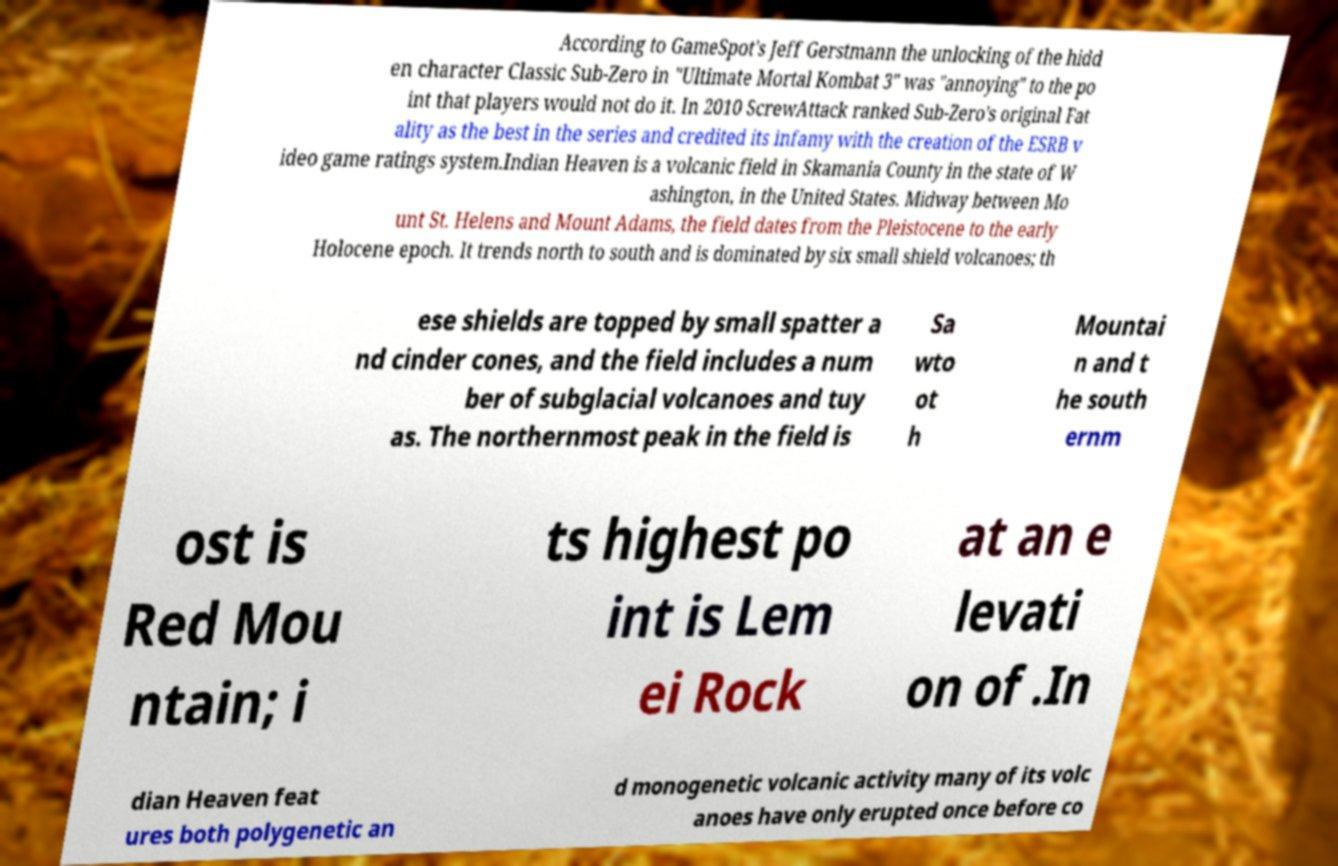Please read and relay the text visible in this image. What does it say? According to GameSpot's Jeff Gerstmann the unlocking of the hidd en character Classic Sub-Zero in "Ultimate Mortal Kombat 3" was "annoying" to the po int that players would not do it. In 2010 ScrewAttack ranked Sub-Zero's original Fat ality as the best in the series and credited its infamy with the creation of the ESRB v ideo game ratings system.Indian Heaven is a volcanic field in Skamania County in the state of W ashington, in the United States. Midway between Mo unt St. Helens and Mount Adams, the field dates from the Pleistocene to the early Holocene epoch. It trends north to south and is dominated by six small shield volcanoes; th ese shields are topped by small spatter a nd cinder cones, and the field includes a num ber of subglacial volcanoes and tuy as. The northernmost peak in the field is Sa wto ot h Mountai n and t he south ernm ost is Red Mou ntain; i ts highest po int is Lem ei Rock at an e levati on of .In dian Heaven feat ures both polygenetic an d monogenetic volcanic activity many of its volc anoes have only erupted once before co 